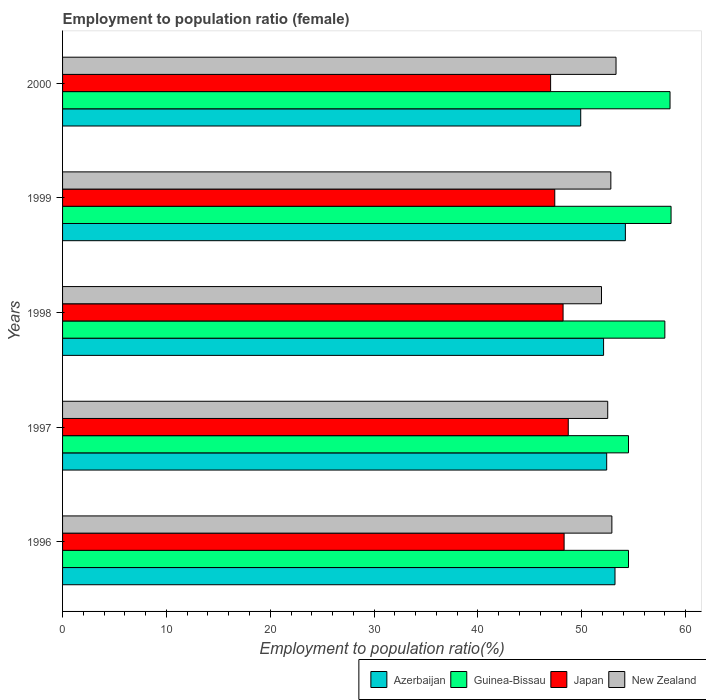How many different coloured bars are there?
Provide a succinct answer. 4. How many groups of bars are there?
Your answer should be very brief. 5. Are the number of bars on each tick of the Y-axis equal?
Your response must be concise. Yes. What is the employment to population ratio in Azerbaijan in 1997?
Offer a terse response. 52.4. Across all years, what is the maximum employment to population ratio in Japan?
Your response must be concise. 48.7. Across all years, what is the minimum employment to population ratio in New Zealand?
Your answer should be very brief. 51.9. What is the total employment to population ratio in New Zealand in the graph?
Give a very brief answer. 263.4. What is the difference between the employment to population ratio in Azerbaijan in 1996 and that in 1997?
Offer a terse response. 0.8. What is the difference between the employment to population ratio in Azerbaijan in 1997 and the employment to population ratio in Guinea-Bissau in 1999?
Offer a terse response. -6.2. What is the average employment to population ratio in Guinea-Bissau per year?
Offer a very short reply. 56.82. In the year 1998, what is the difference between the employment to population ratio in New Zealand and employment to population ratio in Guinea-Bissau?
Provide a succinct answer. -6.1. In how many years, is the employment to population ratio in New Zealand greater than 40 %?
Keep it short and to the point. 5. What is the ratio of the employment to population ratio in Guinea-Bissau in 1997 to that in 1998?
Provide a succinct answer. 0.94. Is the difference between the employment to population ratio in New Zealand in 1996 and 1998 greater than the difference between the employment to population ratio in Guinea-Bissau in 1996 and 1998?
Your response must be concise. Yes. What is the difference between the highest and the second highest employment to population ratio in New Zealand?
Offer a very short reply. 0.4. What is the difference between the highest and the lowest employment to population ratio in Azerbaijan?
Provide a succinct answer. 4.3. In how many years, is the employment to population ratio in Azerbaijan greater than the average employment to population ratio in Azerbaijan taken over all years?
Make the answer very short. 3. Is the sum of the employment to population ratio in Guinea-Bissau in 1999 and 2000 greater than the maximum employment to population ratio in New Zealand across all years?
Ensure brevity in your answer.  Yes. Is it the case that in every year, the sum of the employment to population ratio in Azerbaijan and employment to population ratio in Japan is greater than the sum of employment to population ratio in New Zealand and employment to population ratio in Guinea-Bissau?
Your answer should be compact. No. What does the 4th bar from the bottom in 1996 represents?
Your answer should be very brief. New Zealand. Is it the case that in every year, the sum of the employment to population ratio in Guinea-Bissau and employment to population ratio in New Zealand is greater than the employment to population ratio in Japan?
Offer a terse response. Yes. How many bars are there?
Ensure brevity in your answer.  20. What is the difference between two consecutive major ticks on the X-axis?
Provide a succinct answer. 10. Are the values on the major ticks of X-axis written in scientific E-notation?
Provide a succinct answer. No. Does the graph contain any zero values?
Give a very brief answer. No. Where does the legend appear in the graph?
Make the answer very short. Bottom right. How many legend labels are there?
Your response must be concise. 4. How are the legend labels stacked?
Offer a terse response. Horizontal. What is the title of the graph?
Offer a terse response. Employment to population ratio (female). Does "Estonia" appear as one of the legend labels in the graph?
Provide a succinct answer. No. What is the label or title of the Y-axis?
Your response must be concise. Years. What is the Employment to population ratio(%) of Azerbaijan in 1996?
Offer a very short reply. 53.2. What is the Employment to population ratio(%) in Guinea-Bissau in 1996?
Keep it short and to the point. 54.5. What is the Employment to population ratio(%) in Japan in 1996?
Your response must be concise. 48.3. What is the Employment to population ratio(%) of New Zealand in 1996?
Give a very brief answer. 52.9. What is the Employment to population ratio(%) of Azerbaijan in 1997?
Your answer should be very brief. 52.4. What is the Employment to population ratio(%) in Guinea-Bissau in 1997?
Give a very brief answer. 54.5. What is the Employment to population ratio(%) of Japan in 1997?
Provide a succinct answer. 48.7. What is the Employment to population ratio(%) of New Zealand in 1997?
Your answer should be very brief. 52.5. What is the Employment to population ratio(%) in Azerbaijan in 1998?
Offer a very short reply. 52.1. What is the Employment to population ratio(%) in Japan in 1998?
Give a very brief answer. 48.2. What is the Employment to population ratio(%) of New Zealand in 1998?
Your answer should be very brief. 51.9. What is the Employment to population ratio(%) in Azerbaijan in 1999?
Offer a terse response. 54.2. What is the Employment to population ratio(%) in Guinea-Bissau in 1999?
Make the answer very short. 58.6. What is the Employment to population ratio(%) of Japan in 1999?
Ensure brevity in your answer.  47.4. What is the Employment to population ratio(%) in New Zealand in 1999?
Your answer should be very brief. 52.8. What is the Employment to population ratio(%) in Azerbaijan in 2000?
Offer a very short reply. 49.9. What is the Employment to population ratio(%) in Guinea-Bissau in 2000?
Keep it short and to the point. 58.5. What is the Employment to population ratio(%) in Japan in 2000?
Your answer should be very brief. 47. What is the Employment to population ratio(%) in New Zealand in 2000?
Your response must be concise. 53.3. Across all years, what is the maximum Employment to population ratio(%) in Azerbaijan?
Offer a very short reply. 54.2. Across all years, what is the maximum Employment to population ratio(%) in Guinea-Bissau?
Your answer should be very brief. 58.6. Across all years, what is the maximum Employment to population ratio(%) of Japan?
Your answer should be compact. 48.7. Across all years, what is the maximum Employment to population ratio(%) in New Zealand?
Keep it short and to the point. 53.3. Across all years, what is the minimum Employment to population ratio(%) of Azerbaijan?
Provide a short and direct response. 49.9. Across all years, what is the minimum Employment to population ratio(%) in Guinea-Bissau?
Your response must be concise. 54.5. Across all years, what is the minimum Employment to population ratio(%) in New Zealand?
Provide a succinct answer. 51.9. What is the total Employment to population ratio(%) of Azerbaijan in the graph?
Give a very brief answer. 261.8. What is the total Employment to population ratio(%) in Guinea-Bissau in the graph?
Offer a terse response. 284.1. What is the total Employment to population ratio(%) of Japan in the graph?
Offer a terse response. 239.6. What is the total Employment to population ratio(%) of New Zealand in the graph?
Offer a very short reply. 263.4. What is the difference between the Employment to population ratio(%) of Azerbaijan in 1996 and that in 1997?
Keep it short and to the point. 0.8. What is the difference between the Employment to population ratio(%) in New Zealand in 1996 and that in 1997?
Ensure brevity in your answer.  0.4. What is the difference between the Employment to population ratio(%) of New Zealand in 1996 and that in 1998?
Keep it short and to the point. 1. What is the difference between the Employment to population ratio(%) in Azerbaijan in 1996 and that in 1999?
Offer a terse response. -1. What is the difference between the Employment to population ratio(%) of Guinea-Bissau in 1996 and that in 1999?
Offer a very short reply. -4.1. What is the difference between the Employment to population ratio(%) of Azerbaijan in 1996 and that in 2000?
Your answer should be compact. 3.3. What is the difference between the Employment to population ratio(%) of Guinea-Bissau in 1996 and that in 2000?
Give a very brief answer. -4. What is the difference between the Employment to population ratio(%) in Japan in 1996 and that in 2000?
Give a very brief answer. 1.3. What is the difference between the Employment to population ratio(%) in New Zealand in 1996 and that in 2000?
Make the answer very short. -0.4. What is the difference between the Employment to population ratio(%) in Guinea-Bissau in 1997 and that in 1998?
Keep it short and to the point. -3.5. What is the difference between the Employment to population ratio(%) of Japan in 1997 and that in 2000?
Provide a short and direct response. 1.7. What is the difference between the Employment to population ratio(%) in Guinea-Bissau in 1998 and that in 1999?
Ensure brevity in your answer.  -0.6. What is the difference between the Employment to population ratio(%) of Japan in 1998 and that in 1999?
Your response must be concise. 0.8. What is the difference between the Employment to population ratio(%) in New Zealand in 1998 and that in 1999?
Provide a succinct answer. -0.9. What is the difference between the Employment to population ratio(%) in New Zealand in 1998 and that in 2000?
Make the answer very short. -1.4. What is the difference between the Employment to population ratio(%) of Azerbaijan in 1999 and that in 2000?
Offer a very short reply. 4.3. What is the difference between the Employment to population ratio(%) in Guinea-Bissau in 1999 and that in 2000?
Your answer should be compact. 0.1. What is the difference between the Employment to population ratio(%) of New Zealand in 1999 and that in 2000?
Make the answer very short. -0.5. What is the difference between the Employment to population ratio(%) in Guinea-Bissau in 1996 and the Employment to population ratio(%) in Japan in 1997?
Provide a succinct answer. 5.8. What is the difference between the Employment to population ratio(%) of Japan in 1996 and the Employment to population ratio(%) of New Zealand in 1997?
Provide a succinct answer. -4.2. What is the difference between the Employment to population ratio(%) in Azerbaijan in 1996 and the Employment to population ratio(%) in Guinea-Bissau in 1998?
Give a very brief answer. -4.8. What is the difference between the Employment to population ratio(%) of Azerbaijan in 1996 and the Employment to population ratio(%) of New Zealand in 1998?
Give a very brief answer. 1.3. What is the difference between the Employment to population ratio(%) in Guinea-Bissau in 1996 and the Employment to population ratio(%) in Japan in 1998?
Provide a succinct answer. 6.3. What is the difference between the Employment to population ratio(%) of Guinea-Bissau in 1996 and the Employment to population ratio(%) of New Zealand in 1998?
Offer a terse response. 2.6. What is the difference between the Employment to population ratio(%) of Azerbaijan in 1996 and the Employment to population ratio(%) of New Zealand in 1999?
Offer a terse response. 0.4. What is the difference between the Employment to population ratio(%) of Guinea-Bissau in 1996 and the Employment to population ratio(%) of New Zealand in 1999?
Ensure brevity in your answer.  1.7. What is the difference between the Employment to population ratio(%) in Japan in 1996 and the Employment to population ratio(%) in New Zealand in 1999?
Keep it short and to the point. -4.5. What is the difference between the Employment to population ratio(%) in Azerbaijan in 1996 and the Employment to population ratio(%) in New Zealand in 2000?
Provide a succinct answer. -0.1. What is the difference between the Employment to population ratio(%) in Guinea-Bissau in 1996 and the Employment to population ratio(%) in New Zealand in 2000?
Your answer should be compact. 1.2. What is the difference between the Employment to population ratio(%) of Japan in 1996 and the Employment to population ratio(%) of New Zealand in 2000?
Ensure brevity in your answer.  -5. What is the difference between the Employment to population ratio(%) of Azerbaijan in 1997 and the Employment to population ratio(%) of New Zealand in 1998?
Offer a very short reply. 0.5. What is the difference between the Employment to population ratio(%) of Guinea-Bissau in 1997 and the Employment to population ratio(%) of Japan in 1998?
Ensure brevity in your answer.  6.3. What is the difference between the Employment to population ratio(%) of Guinea-Bissau in 1997 and the Employment to population ratio(%) of New Zealand in 1998?
Give a very brief answer. 2.6. What is the difference between the Employment to population ratio(%) of Azerbaijan in 1997 and the Employment to population ratio(%) of Japan in 1999?
Your response must be concise. 5. What is the difference between the Employment to population ratio(%) in Guinea-Bissau in 1997 and the Employment to population ratio(%) in Japan in 1999?
Your answer should be compact. 7.1. What is the difference between the Employment to population ratio(%) of Japan in 1997 and the Employment to population ratio(%) of New Zealand in 1999?
Provide a succinct answer. -4.1. What is the difference between the Employment to population ratio(%) of Azerbaijan in 1997 and the Employment to population ratio(%) of Guinea-Bissau in 2000?
Make the answer very short. -6.1. What is the difference between the Employment to population ratio(%) of Azerbaijan in 1997 and the Employment to population ratio(%) of Japan in 2000?
Your answer should be very brief. 5.4. What is the difference between the Employment to population ratio(%) in Azerbaijan in 1997 and the Employment to population ratio(%) in New Zealand in 2000?
Your answer should be very brief. -0.9. What is the difference between the Employment to population ratio(%) in Japan in 1997 and the Employment to population ratio(%) in New Zealand in 2000?
Provide a succinct answer. -4.6. What is the difference between the Employment to population ratio(%) of Azerbaijan in 1998 and the Employment to population ratio(%) of Guinea-Bissau in 1999?
Your answer should be compact. -6.5. What is the difference between the Employment to population ratio(%) in Azerbaijan in 1998 and the Employment to population ratio(%) in Japan in 1999?
Your answer should be compact. 4.7. What is the difference between the Employment to population ratio(%) in Azerbaijan in 1998 and the Employment to population ratio(%) in New Zealand in 1999?
Offer a very short reply. -0.7. What is the difference between the Employment to population ratio(%) of Azerbaijan in 1998 and the Employment to population ratio(%) of Japan in 2000?
Your response must be concise. 5.1. What is the difference between the Employment to population ratio(%) of Azerbaijan in 1998 and the Employment to population ratio(%) of New Zealand in 2000?
Keep it short and to the point. -1.2. What is the difference between the Employment to population ratio(%) in Japan in 1998 and the Employment to population ratio(%) in New Zealand in 2000?
Keep it short and to the point. -5.1. What is the difference between the Employment to population ratio(%) in Azerbaijan in 1999 and the Employment to population ratio(%) in New Zealand in 2000?
Ensure brevity in your answer.  0.9. What is the average Employment to population ratio(%) of Azerbaijan per year?
Provide a short and direct response. 52.36. What is the average Employment to population ratio(%) of Guinea-Bissau per year?
Offer a very short reply. 56.82. What is the average Employment to population ratio(%) of Japan per year?
Make the answer very short. 47.92. What is the average Employment to population ratio(%) in New Zealand per year?
Provide a short and direct response. 52.68. In the year 1996, what is the difference between the Employment to population ratio(%) in Azerbaijan and Employment to population ratio(%) in Japan?
Offer a very short reply. 4.9. In the year 1996, what is the difference between the Employment to population ratio(%) of Guinea-Bissau and Employment to population ratio(%) of Japan?
Provide a succinct answer. 6.2. In the year 1996, what is the difference between the Employment to population ratio(%) in Guinea-Bissau and Employment to population ratio(%) in New Zealand?
Offer a very short reply. 1.6. In the year 1997, what is the difference between the Employment to population ratio(%) in Azerbaijan and Employment to population ratio(%) in Japan?
Your answer should be very brief. 3.7. In the year 1997, what is the difference between the Employment to population ratio(%) of Guinea-Bissau and Employment to population ratio(%) of Japan?
Offer a very short reply. 5.8. In the year 1998, what is the difference between the Employment to population ratio(%) in Azerbaijan and Employment to population ratio(%) in Guinea-Bissau?
Offer a terse response. -5.9. In the year 1998, what is the difference between the Employment to population ratio(%) of Azerbaijan and Employment to population ratio(%) of New Zealand?
Your response must be concise. 0.2. In the year 1998, what is the difference between the Employment to population ratio(%) of Guinea-Bissau and Employment to population ratio(%) of Japan?
Ensure brevity in your answer.  9.8. In the year 1998, what is the difference between the Employment to population ratio(%) in Guinea-Bissau and Employment to population ratio(%) in New Zealand?
Provide a short and direct response. 6.1. In the year 1999, what is the difference between the Employment to population ratio(%) in Azerbaijan and Employment to population ratio(%) in Japan?
Ensure brevity in your answer.  6.8. In the year 1999, what is the difference between the Employment to population ratio(%) in Guinea-Bissau and Employment to population ratio(%) in Japan?
Provide a succinct answer. 11.2. In the year 1999, what is the difference between the Employment to population ratio(%) in Guinea-Bissau and Employment to population ratio(%) in New Zealand?
Your response must be concise. 5.8. In the year 1999, what is the difference between the Employment to population ratio(%) in Japan and Employment to population ratio(%) in New Zealand?
Offer a terse response. -5.4. In the year 2000, what is the difference between the Employment to population ratio(%) of Azerbaijan and Employment to population ratio(%) of New Zealand?
Your answer should be very brief. -3.4. What is the ratio of the Employment to population ratio(%) in Azerbaijan in 1996 to that in 1997?
Keep it short and to the point. 1.02. What is the ratio of the Employment to population ratio(%) of Guinea-Bissau in 1996 to that in 1997?
Make the answer very short. 1. What is the ratio of the Employment to population ratio(%) of New Zealand in 1996 to that in 1997?
Your answer should be compact. 1.01. What is the ratio of the Employment to population ratio(%) of Azerbaijan in 1996 to that in 1998?
Your answer should be compact. 1.02. What is the ratio of the Employment to population ratio(%) of Guinea-Bissau in 1996 to that in 1998?
Provide a short and direct response. 0.94. What is the ratio of the Employment to population ratio(%) of Japan in 1996 to that in 1998?
Ensure brevity in your answer.  1. What is the ratio of the Employment to population ratio(%) in New Zealand in 1996 to that in 1998?
Offer a terse response. 1.02. What is the ratio of the Employment to population ratio(%) of Azerbaijan in 1996 to that in 1999?
Your response must be concise. 0.98. What is the ratio of the Employment to population ratio(%) of Guinea-Bissau in 1996 to that in 1999?
Provide a succinct answer. 0.93. What is the ratio of the Employment to population ratio(%) in New Zealand in 1996 to that in 1999?
Ensure brevity in your answer.  1. What is the ratio of the Employment to population ratio(%) of Azerbaijan in 1996 to that in 2000?
Give a very brief answer. 1.07. What is the ratio of the Employment to population ratio(%) in Guinea-Bissau in 1996 to that in 2000?
Make the answer very short. 0.93. What is the ratio of the Employment to population ratio(%) in Japan in 1996 to that in 2000?
Keep it short and to the point. 1.03. What is the ratio of the Employment to population ratio(%) in New Zealand in 1996 to that in 2000?
Your response must be concise. 0.99. What is the ratio of the Employment to population ratio(%) in Guinea-Bissau in 1997 to that in 1998?
Make the answer very short. 0.94. What is the ratio of the Employment to population ratio(%) in Japan in 1997 to that in 1998?
Make the answer very short. 1.01. What is the ratio of the Employment to population ratio(%) in New Zealand in 1997 to that in 1998?
Your answer should be very brief. 1.01. What is the ratio of the Employment to population ratio(%) in Azerbaijan in 1997 to that in 1999?
Provide a succinct answer. 0.97. What is the ratio of the Employment to population ratio(%) in Japan in 1997 to that in 1999?
Offer a very short reply. 1.03. What is the ratio of the Employment to population ratio(%) in Azerbaijan in 1997 to that in 2000?
Your response must be concise. 1.05. What is the ratio of the Employment to population ratio(%) in Guinea-Bissau in 1997 to that in 2000?
Keep it short and to the point. 0.93. What is the ratio of the Employment to population ratio(%) of Japan in 1997 to that in 2000?
Provide a succinct answer. 1.04. What is the ratio of the Employment to population ratio(%) in Azerbaijan in 1998 to that in 1999?
Give a very brief answer. 0.96. What is the ratio of the Employment to population ratio(%) of Japan in 1998 to that in 1999?
Your response must be concise. 1.02. What is the ratio of the Employment to population ratio(%) in Azerbaijan in 1998 to that in 2000?
Provide a short and direct response. 1.04. What is the ratio of the Employment to population ratio(%) of Guinea-Bissau in 1998 to that in 2000?
Make the answer very short. 0.99. What is the ratio of the Employment to population ratio(%) of Japan in 1998 to that in 2000?
Ensure brevity in your answer.  1.03. What is the ratio of the Employment to population ratio(%) in New Zealand in 1998 to that in 2000?
Provide a succinct answer. 0.97. What is the ratio of the Employment to population ratio(%) of Azerbaijan in 1999 to that in 2000?
Ensure brevity in your answer.  1.09. What is the ratio of the Employment to population ratio(%) of Japan in 1999 to that in 2000?
Provide a short and direct response. 1.01. What is the ratio of the Employment to population ratio(%) of New Zealand in 1999 to that in 2000?
Offer a terse response. 0.99. What is the difference between the highest and the second highest Employment to population ratio(%) in Azerbaijan?
Give a very brief answer. 1. What is the difference between the highest and the second highest Employment to population ratio(%) of Japan?
Give a very brief answer. 0.4. What is the difference between the highest and the lowest Employment to population ratio(%) in Azerbaijan?
Provide a succinct answer. 4.3. What is the difference between the highest and the lowest Employment to population ratio(%) of New Zealand?
Give a very brief answer. 1.4. 